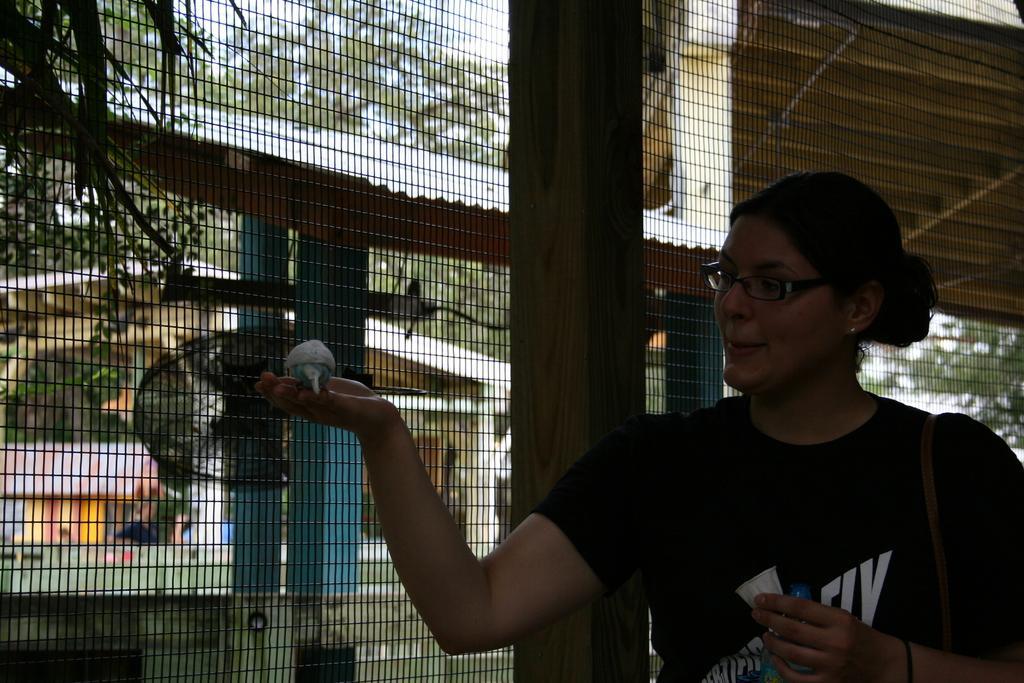Please provide a concise description of this image. A woman is standing at the right side wearing a black t shirt. There is a bird on her palm. There is a fence, buildings and trees at the back. 